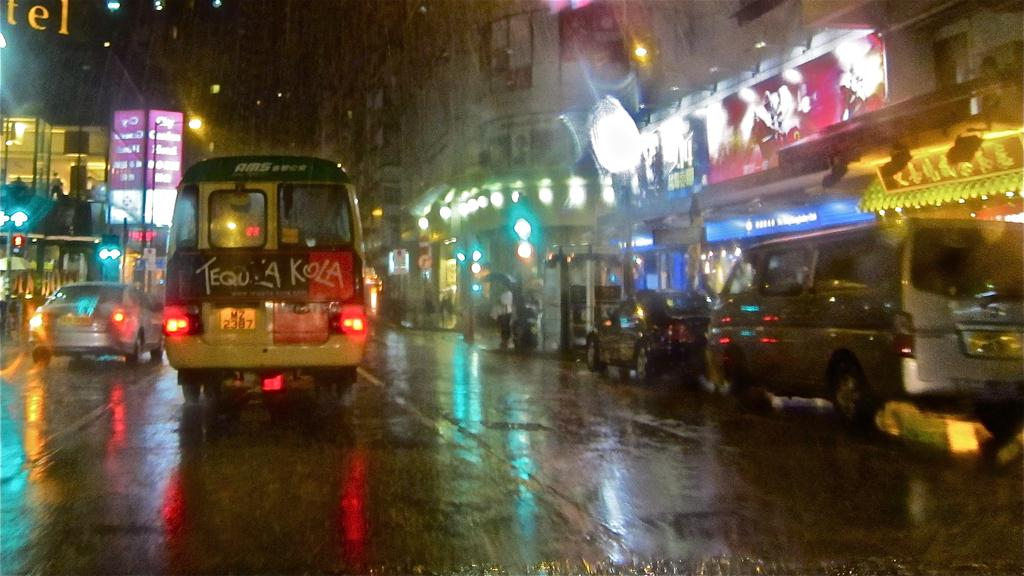Provide a one-sentence caption for the provided image. A bus on a wet street and it says Tequ A Kola on the back. 